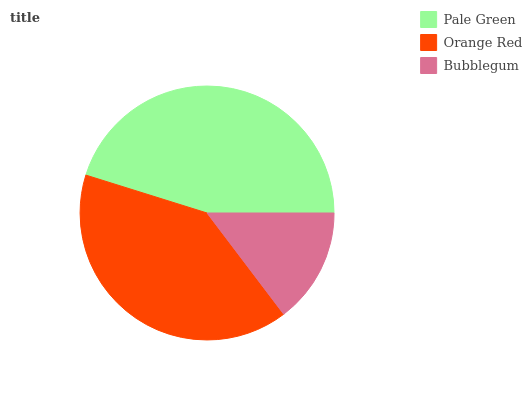Is Bubblegum the minimum?
Answer yes or no. Yes. Is Pale Green the maximum?
Answer yes or no. Yes. Is Orange Red the minimum?
Answer yes or no. No. Is Orange Red the maximum?
Answer yes or no. No. Is Pale Green greater than Orange Red?
Answer yes or no. Yes. Is Orange Red less than Pale Green?
Answer yes or no. Yes. Is Orange Red greater than Pale Green?
Answer yes or no. No. Is Pale Green less than Orange Red?
Answer yes or no. No. Is Orange Red the high median?
Answer yes or no. Yes. Is Orange Red the low median?
Answer yes or no. Yes. Is Bubblegum the high median?
Answer yes or no. No. Is Pale Green the low median?
Answer yes or no. No. 